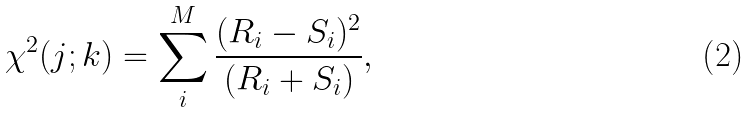<formula> <loc_0><loc_0><loc_500><loc_500>\chi ^ { 2 } ( j ; k ) = \sum _ { i } ^ { M } \frac { ( R _ { i } - S _ { i } ) ^ { 2 } } { ( R _ { i } + S _ { i } ) } ,</formula> 